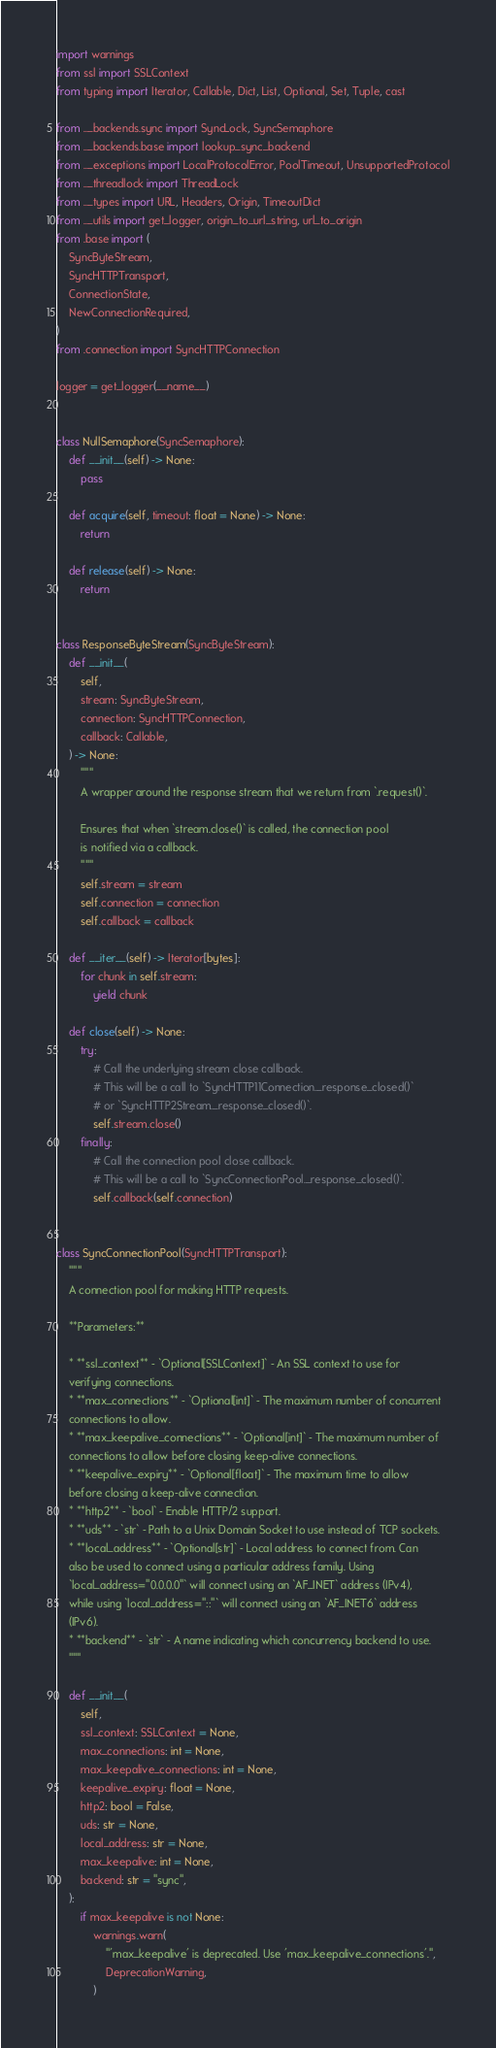Convert code to text. <code><loc_0><loc_0><loc_500><loc_500><_Python_>import warnings
from ssl import SSLContext
from typing import Iterator, Callable, Dict, List, Optional, Set, Tuple, cast

from .._backends.sync import SyncLock, SyncSemaphore
from .._backends.base import lookup_sync_backend
from .._exceptions import LocalProtocolError, PoolTimeout, UnsupportedProtocol
from .._threadlock import ThreadLock
from .._types import URL, Headers, Origin, TimeoutDict
from .._utils import get_logger, origin_to_url_string, url_to_origin
from .base import (
    SyncByteStream,
    SyncHTTPTransport,
    ConnectionState,
    NewConnectionRequired,
)
from .connection import SyncHTTPConnection

logger = get_logger(__name__)


class NullSemaphore(SyncSemaphore):
    def __init__(self) -> None:
        pass

    def acquire(self, timeout: float = None) -> None:
        return

    def release(self) -> None:
        return


class ResponseByteStream(SyncByteStream):
    def __init__(
        self,
        stream: SyncByteStream,
        connection: SyncHTTPConnection,
        callback: Callable,
    ) -> None:
        """
        A wrapper around the response stream that we return from `.request()`.

        Ensures that when `stream.close()` is called, the connection pool
        is notified via a callback.
        """
        self.stream = stream
        self.connection = connection
        self.callback = callback

    def __iter__(self) -> Iterator[bytes]:
        for chunk in self.stream:
            yield chunk

    def close(self) -> None:
        try:
            # Call the underlying stream close callback.
            # This will be a call to `SyncHTTP11Connection._response_closed()`
            # or `SyncHTTP2Stream._response_closed()`.
            self.stream.close()
        finally:
            # Call the connection pool close callback.
            # This will be a call to `SyncConnectionPool._response_closed()`.
            self.callback(self.connection)


class SyncConnectionPool(SyncHTTPTransport):
    """
    A connection pool for making HTTP requests.

    **Parameters:**

    * **ssl_context** - `Optional[SSLContext]` - An SSL context to use for
    verifying connections.
    * **max_connections** - `Optional[int]` - The maximum number of concurrent
    connections to allow.
    * **max_keepalive_connections** - `Optional[int]` - The maximum number of
    connections to allow before closing keep-alive connections.
    * **keepalive_expiry** - `Optional[float]` - The maximum time to allow
    before closing a keep-alive connection.
    * **http2** - `bool` - Enable HTTP/2 support.
    * **uds** - `str` - Path to a Unix Domain Socket to use instead of TCP sockets.
    * **local_address** - `Optional[str]` - Local address to connect from. Can
    also be used to connect using a particular address family. Using
    `local_address="0.0.0.0"` will connect using an `AF_INET` address (IPv4),
    while using `local_address="::"` will connect using an `AF_INET6` address
    (IPv6).
    * **backend** - `str` - A name indicating which concurrency backend to use.
    """

    def __init__(
        self,
        ssl_context: SSLContext = None,
        max_connections: int = None,
        max_keepalive_connections: int = None,
        keepalive_expiry: float = None,
        http2: bool = False,
        uds: str = None,
        local_address: str = None,
        max_keepalive: int = None,
        backend: str = "sync",
    ):
        if max_keepalive is not None:
            warnings.warn(
                "'max_keepalive' is deprecated. Use 'max_keepalive_connections'.",
                DeprecationWarning,
            )</code> 